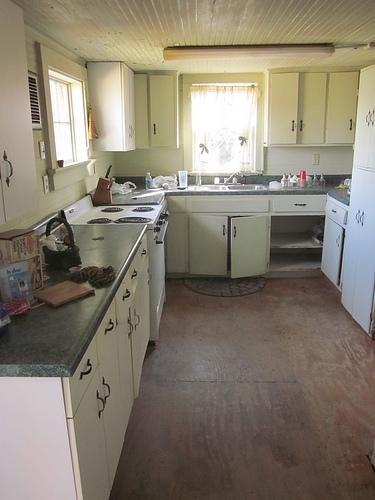Name an object on the countertop and describe its appearance. There is a clear container on the countertop with a rectangular shape and transparent appearance. Describe the texture and appearance of the kitchen wall. The kitchen wall has a white color and smooth texture. There is a white electrical outlet on it as well. What kind of surface can be found on the counter? The counter has a green formica surface. What type of handles can be found on the kitchen cabinets? The cabinets feature black metal handles. How is the window dressed in the kitchen? There are curtains over the window in the kitchen. Identify the color and position of the can. There are multiple red cans placed on top of the counter at different positions. Tell me about the cabinet under the sink in the kitchen. The cabinet underneath the sink is open, showing its contents. Count the number of red cups on the counter. There are 3 red cups on the kitchen counter. Describe the appearance of the kitchen floor. The kitchen floor has hardwood flooring with a rug placed on top of it and a floor mat in front of the sink. Is there any object hanging from the ceiling? If so, describe it. Yes, there is a light hanging from the ceiling with a unique and intricate design. 